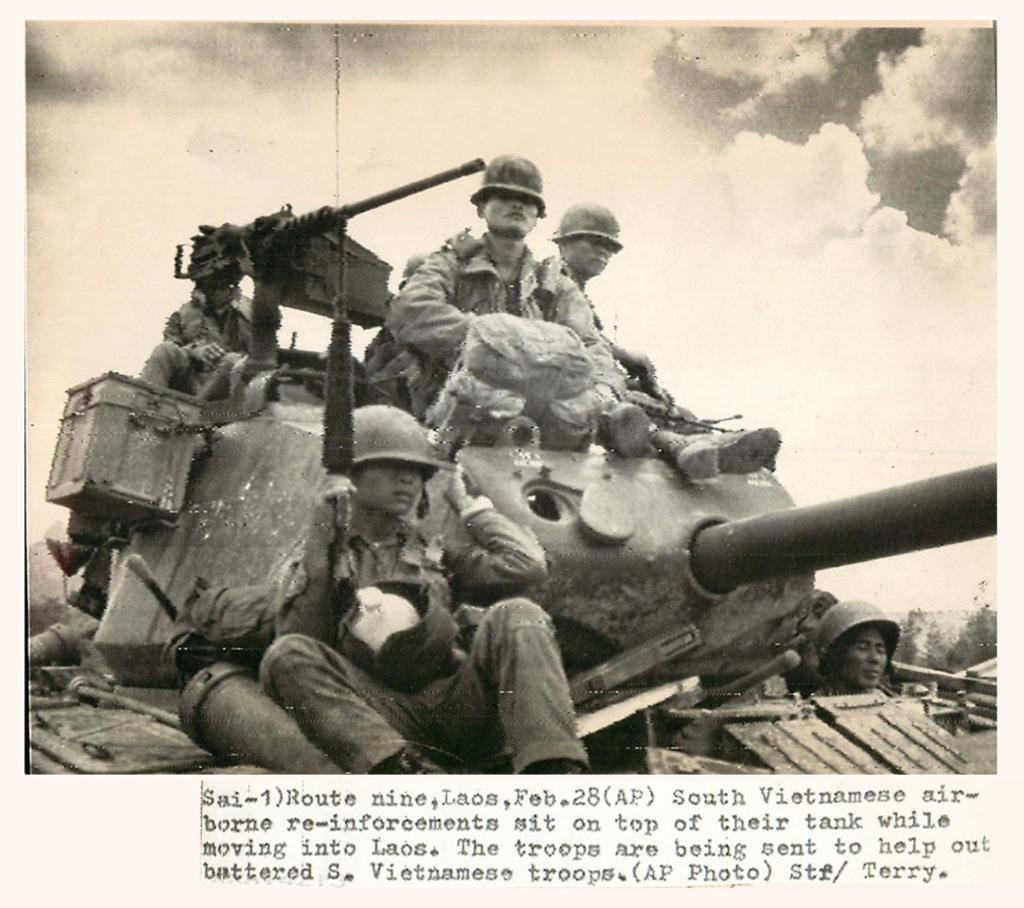What can be seen in the image involving a large vehicle? There is a military tank in the image. Who or what is present in the image besides the military tank? There is a group of people in the image. What is the color scheme of the image? The image is in black and white. Is there any text or writing visible in the image? Yes, there is something written on the image. What type of copper material is being used to construct the military tank in the image? There is no mention of copper or any specific material used to construct the military tank in the image. 